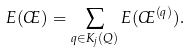Convert formula to latex. <formula><loc_0><loc_0><loc_500><loc_500>E ( \phi ) = \sum _ { q \in K _ { j } ( Q ) } E ( \phi ^ { ( q ) } ) .</formula> 